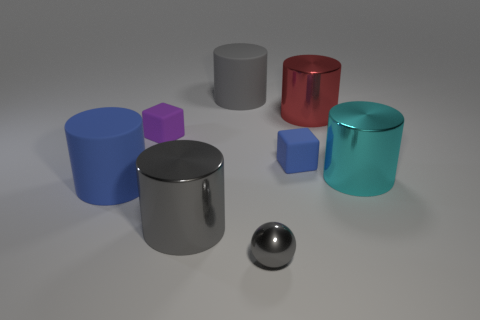Add 1 cyan objects. How many objects exist? 9 Subtract all matte cylinders. How many cylinders are left? 3 Subtract all cyan spheres. How many gray cylinders are left? 2 Subtract all purple blocks. How many blocks are left? 1 Add 7 large red objects. How many large red objects exist? 8 Subtract 0 red balls. How many objects are left? 8 Subtract all cylinders. How many objects are left? 3 Subtract 2 cylinders. How many cylinders are left? 3 Subtract all gray blocks. Subtract all yellow balls. How many blocks are left? 2 Subtract all rubber blocks. Subtract all brown metal cylinders. How many objects are left? 6 